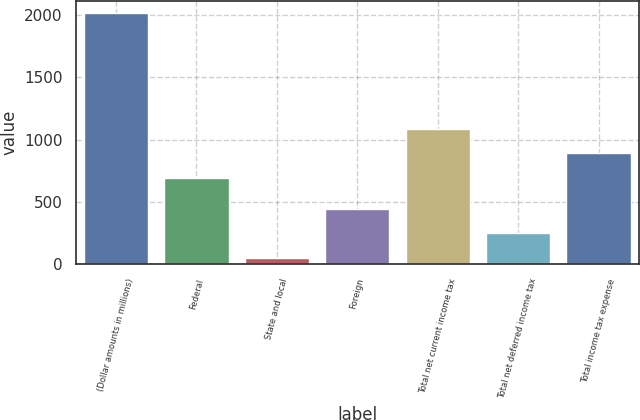<chart> <loc_0><loc_0><loc_500><loc_500><bar_chart><fcel>(Dollar amounts in millions)<fcel>Federal<fcel>State and local<fcel>Foreign<fcel>Total net current income tax<fcel>Total net deferred income tax<fcel>Total income tax expense<nl><fcel>2011<fcel>693<fcel>54<fcel>445.4<fcel>1084.4<fcel>249.7<fcel>888.7<nl></chart> 